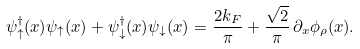Convert formula to latex. <formula><loc_0><loc_0><loc_500><loc_500>\psi _ { \uparrow } ^ { \dagger } ( x ) \psi _ { \uparrow } ( x ) + \psi _ { \downarrow } ^ { \dagger } ( x ) \psi _ { \downarrow } ( x ) = \frac { 2 k _ { F } } { \pi } + \frac { \sqrt { 2 } } { \pi } \, \partial _ { x } \phi _ { \rho } ( x ) .</formula> 